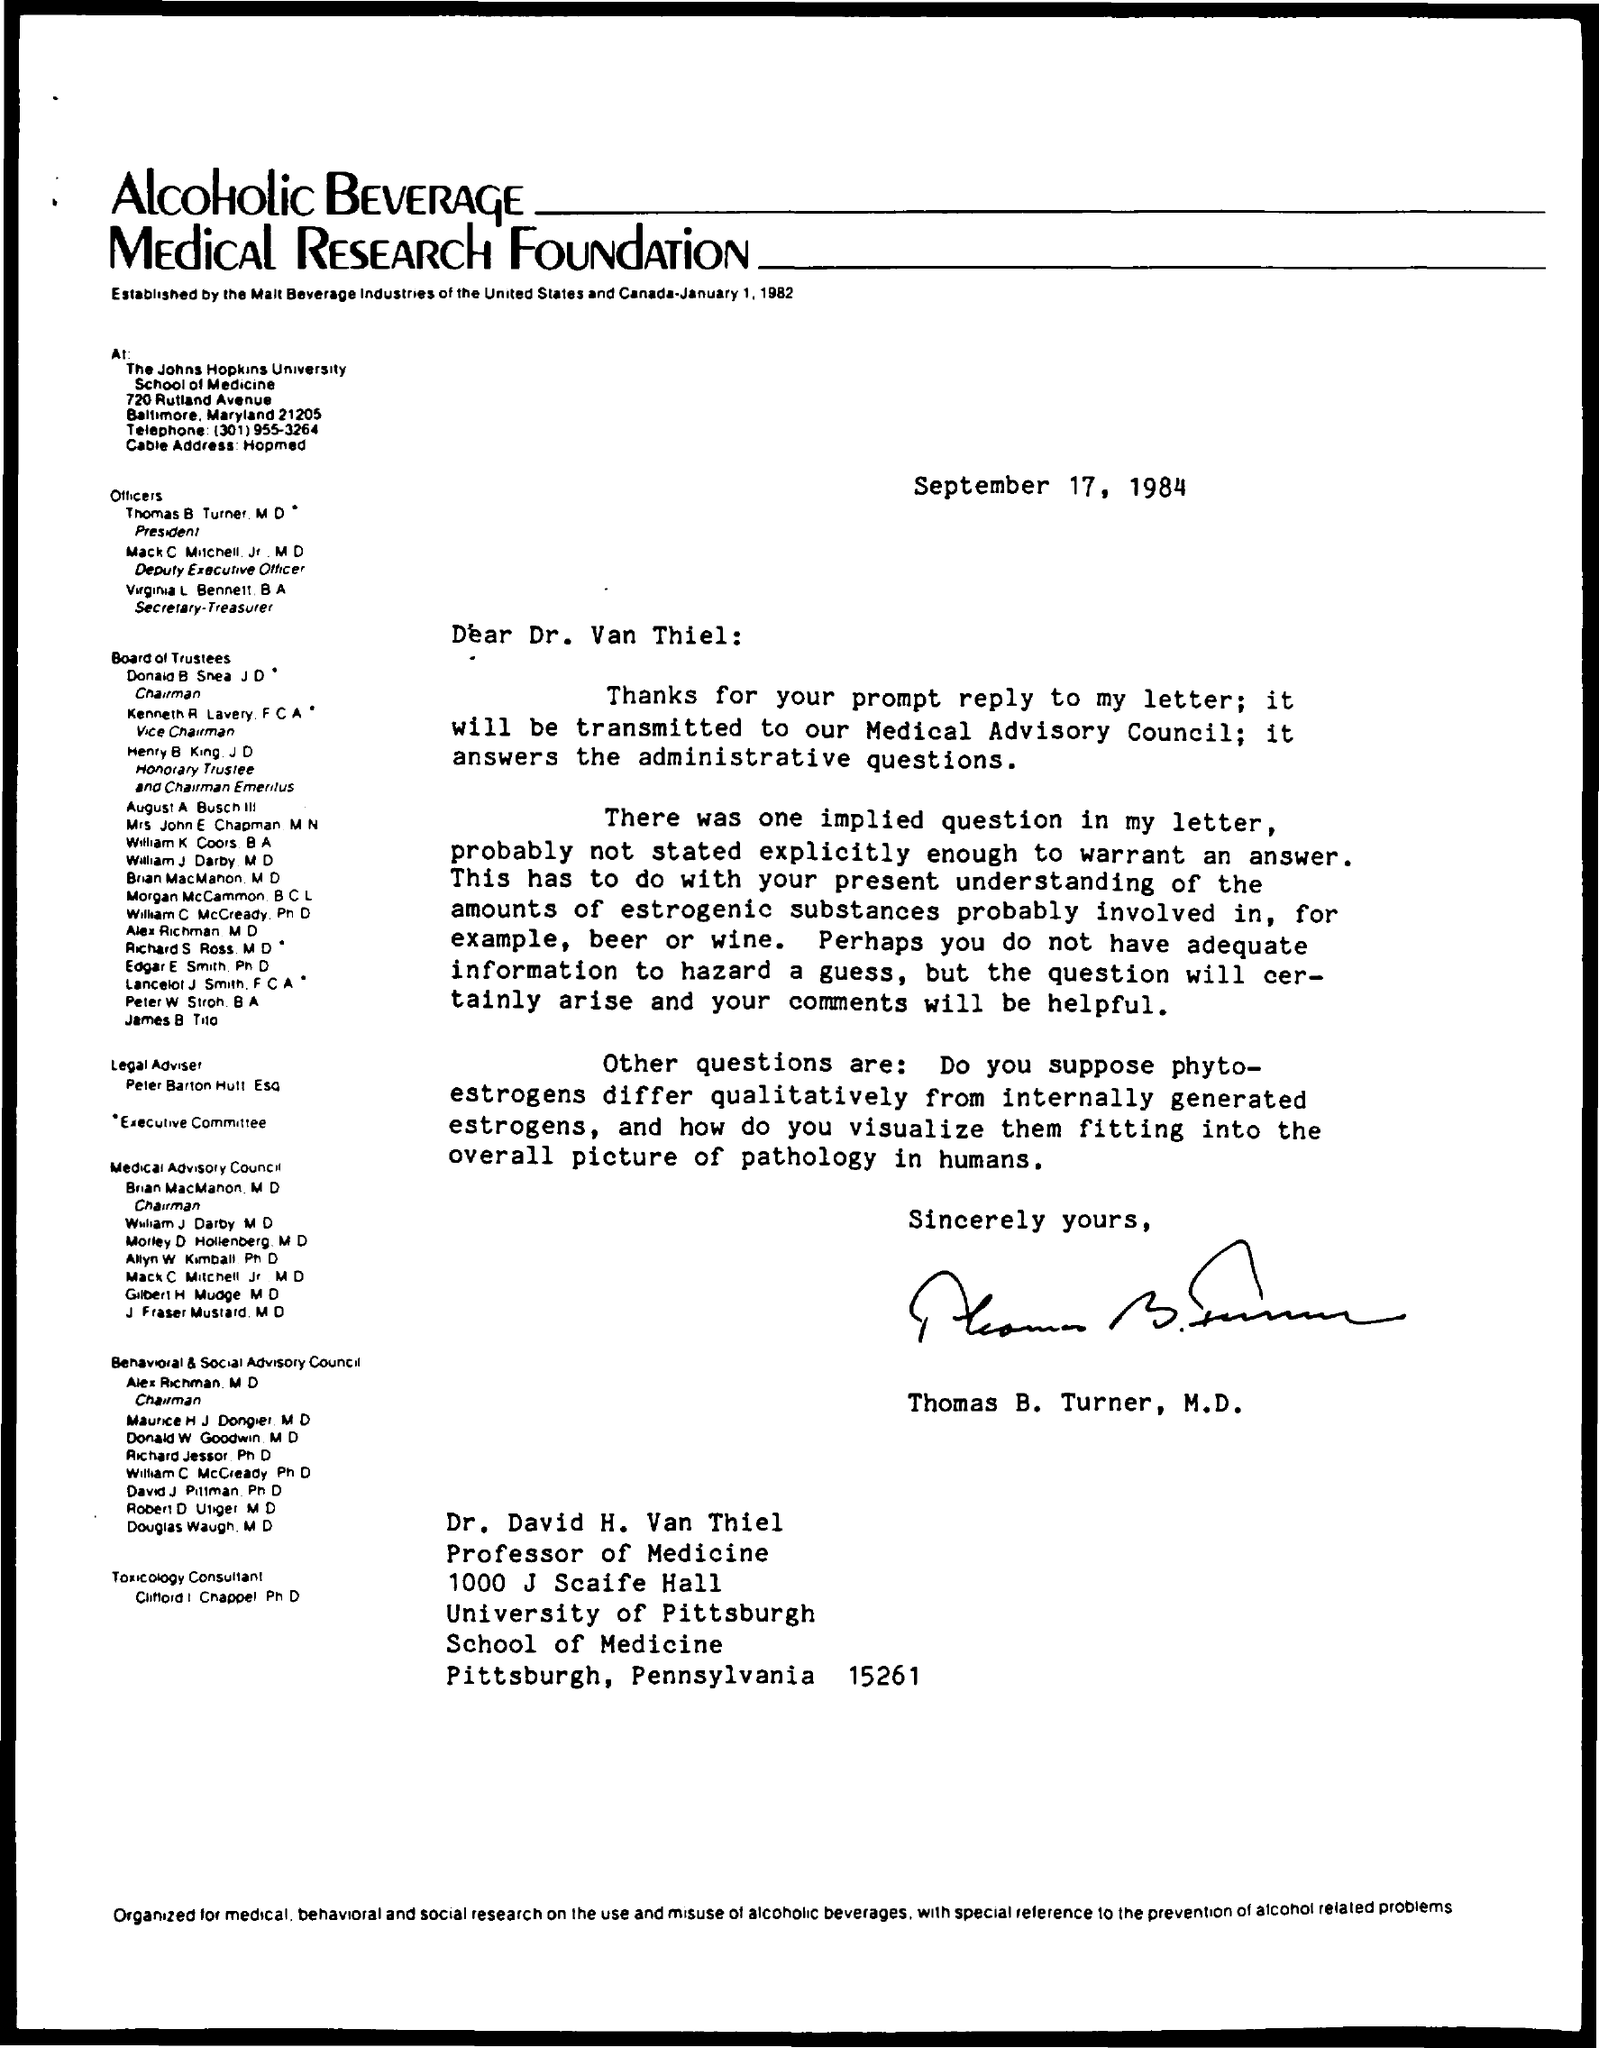What is the date on the document?
Your answer should be very brief. September 17, 1984. To Whom is this letter addressed to?
Provide a succinct answer. Dr. Van Thiel. Who is this letter from?
Offer a terse response. Thomas B. Turner, M.D. 